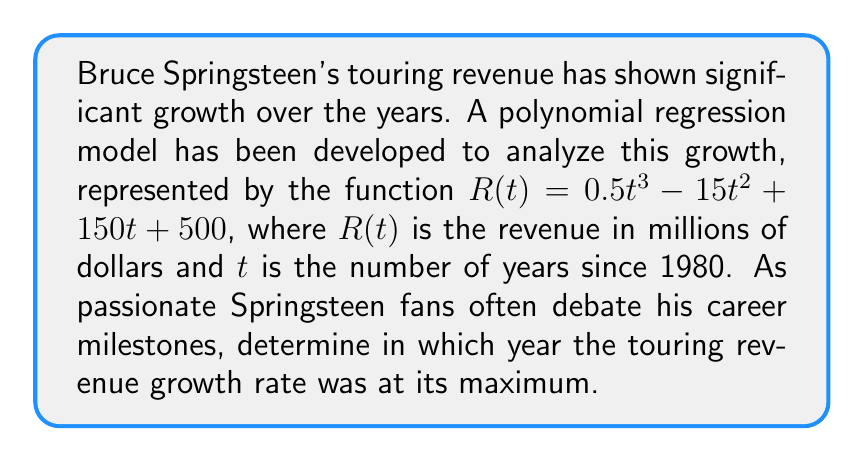Solve this math problem. To find the year when the revenue growth rate was at its maximum, we need to follow these steps:

1) The growth rate is represented by the first derivative of the revenue function. Let's call this $R'(t)$:

   $R'(t) = 1.5t^2 - 30t + 150$

2) The maximum growth rate occurs when the second derivative equals zero. The second derivative is:

   $R''(t) = 3t - 30$

3) Set $R''(t) = 0$ and solve for $t$:

   $3t - 30 = 0$
   $3t = 30$
   $t = 10$

4) To confirm this is a maximum (not a minimum), check that $R'''(t) < 0$:

   $R'''(t) = 3$, which is positive, confirming $t = 10$ gives a minimum of $R'(t)$, or a maximum growth rate.

5) Since $t$ represents years since 1980, we add 10 to 1980 to get the actual year:

   1980 + 10 = 1990

Therefore, the touring revenue growth rate was at its maximum in 1990.
Answer: 1990 